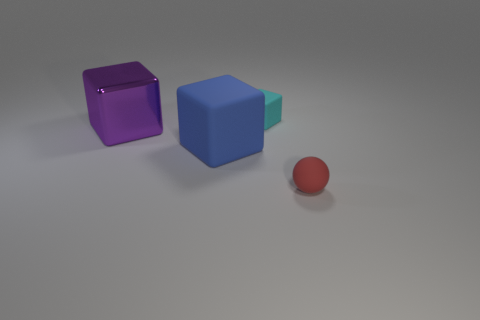Add 3 large blue balls. How many objects exist? 7 Subtract all spheres. How many objects are left? 3 Subtract 1 red spheres. How many objects are left? 3 Subtract all purple metal things. Subtract all blue blocks. How many objects are left? 2 Add 2 small matte spheres. How many small matte spheres are left? 3 Add 2 blue objects. How many blue objects exist? 3 